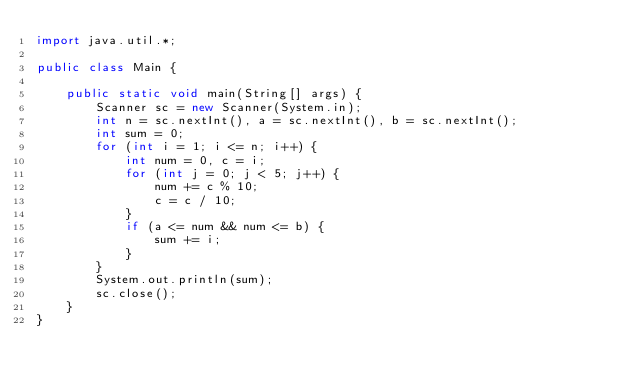<code> <loc_0><loc_0><loc_500><loc_500><_Java_>import java.util.*;

public class Main {

	public static void main(String[] args) {
		Scanner sc = new Scanner(System.in);
		int n = sc.nextInt(), a = sc.nextInt(), b = sc.nextInt();
		int sum = 0;
		for (int i = 1; i <= n; i++) {
			int num = 0, c = i;
			for (int j = 0; j < 5; j++) {
				num += c % 10;
				c = c / 10;
			}
			if (a <= num && num <= b) {
				sum += i;
			}
		}
		System.out.println(sum);
		sc.close();
	}
}
</code> 